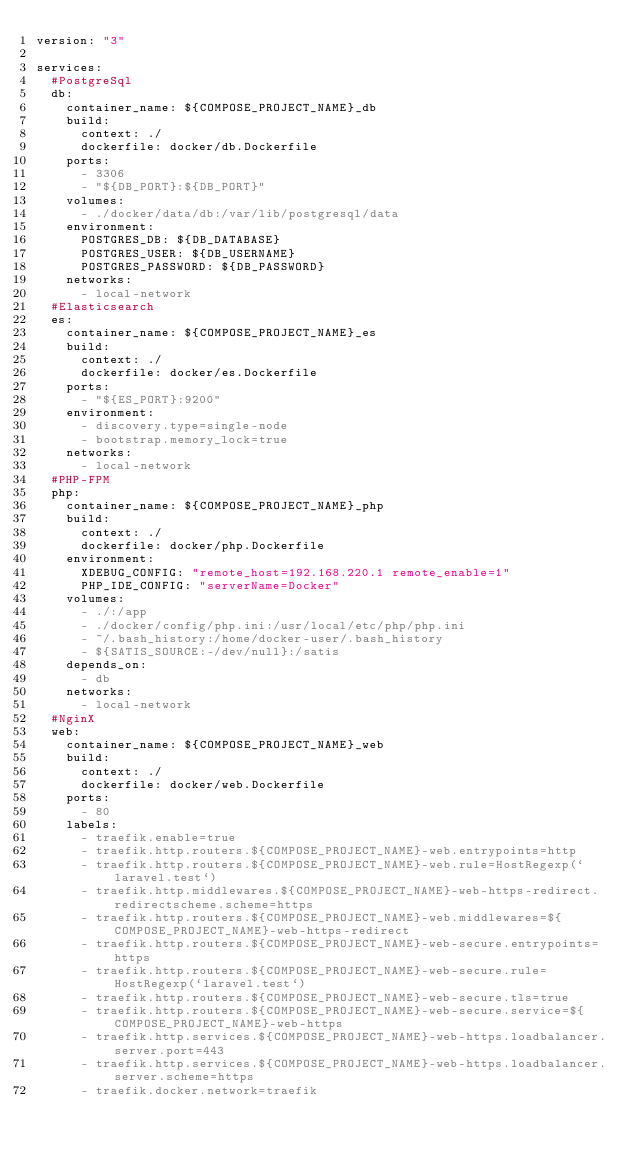<code> <loc_0><loc_0><loc_500><loc_500><_YAML_>version: "3"

services:
  #PostgreSql
  db:
    container_name: ${COMPOSE_PROJECT_NAME}_db
    build:
      context: ./
      dockerfile: docker/db.Dockerfile
    ports:
      - 3306
      - "${DB_PORT}:${DB_PORT}"
    volumes:
      - ./docker/data/db:/var/lib/postgresql/data
    environment:
      POSTGRES_DB: ${DB_DATABASE}
      POSTGRES_USER: ${DB_USERNAME}
      POSTGRES_PASSWORD: ${DB_PASSWORD}
    networks:
      - local-network
  #Elasticsearch
  es:
    container_name: ${COMPOSE_PROJECT_NAME}_es
    build:
      context: ./
      dockerfile: docker/es.Dockerfile
    ports:
      - "${ES_PORT}:9200"
    environment:
      - discovery.type=single-node
      - bootstrap.memory_lock=true
    networks:
      - local-network
  #PHP-FPM
  php:
    container_name: ${COMPOSE_PROJECT_NAME}_php
    build:
      context: ./
      dockerfile: docker/php.Dockerfile
    environment:
      XDEBUG_CONFIG: "remote_host=192.168.220.1 remote_enable=1"
      PHP_IDE_CONFIG: "serverName=Docker"
    volumes:
      - ./:/app
      - ./docker/config/php.ini:/usr/local/etc/php/php.ini
      - ~/.bash_history:/home/docker-user/.bash_history
      - ${SATIS_SOURCE:-/dev/null}:/satis
    depends_on:
      - db
    networks:
      - local-network
  #NginX
  web:
    container_name: ${COMPOSE_PROJECT_NAME}_web
    build:
      context: ./
      dockerfile: docker/web.Dockerfile
    ports:
      - 80
    labels:
      - traefik.enable=true
      - traefik.http.routers.${COMPOSE_PROJECT_NAME}-web.entrypoints=http
      - traefik.http.routers.${COMPOSE_PROJECT_NAME}-web.rule=HostRegexp(`laravel.test`)
      - traefik.http.middlewares.${COMPOSE_PROJECT_NAME}-web-https-redirect.redirectscheme.scheme=https
      - traefik.http.routers.${COMPOSE_PROJECT_NAME}-web.middlewares=${COMPOSE_PROJECT_NAME}-web-https-redirect
      - traefik.http.routers.${COMPOSE_PROJECT_NAME}-web-secure.entrypoints=https
      - traefik.http.routers.${COMPOSE_PROJECT_NAME}-web-secure.rule=HostRegexp(`laravel.test`)
      - traefik.http.routers.${COMPOSE_PROJECT_NAME}-web-secure.tls=true
      - traefik.http.routers.${COMPOSE_PROJECT_NAME}-web-secure.service=${COMPOSE_PROJECT_NAME}-web-https
      - traefik.http.services.${COMPOSE_PROJECT_NAME}-web-https.loadbalancer.server.port=443
      - traefik.http.services.${COMPOSE_PROJECT_NAME}-web-https.loadbalancer.server.scheme=https
      - traefik.docker.network=traefik</code> 